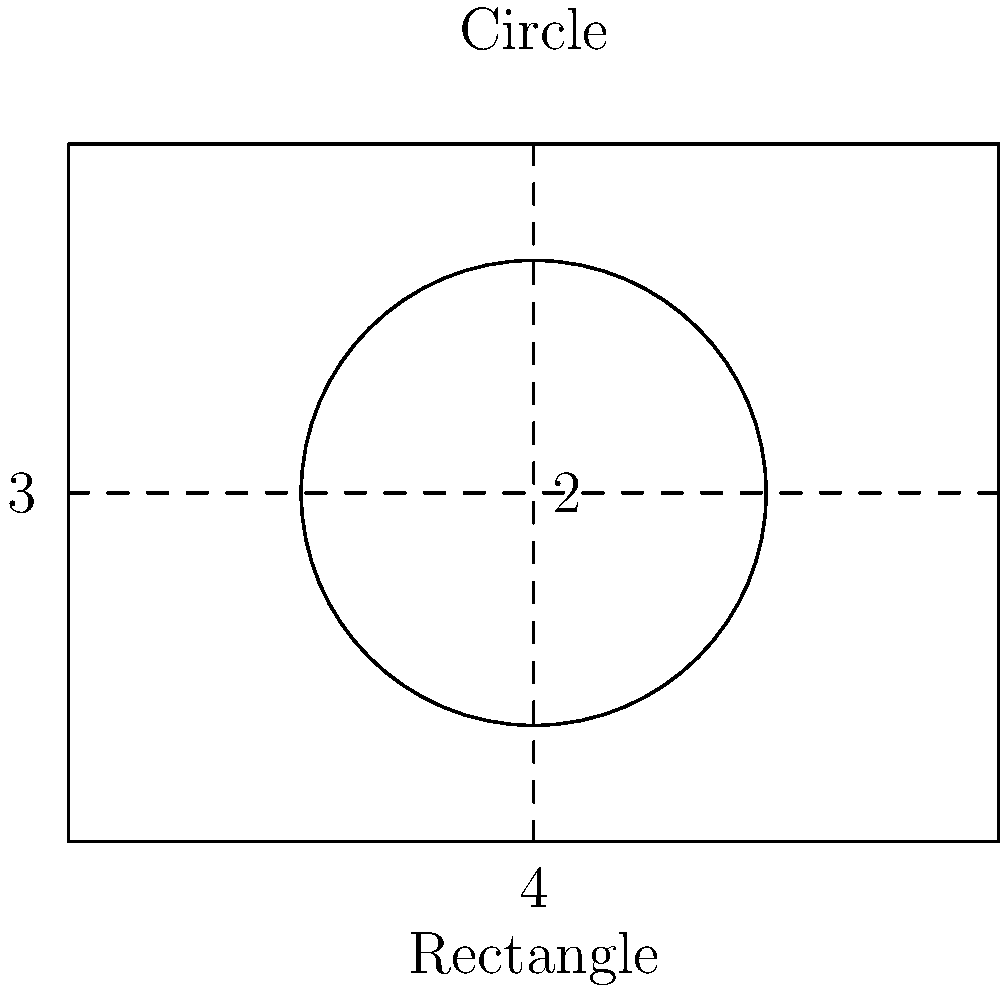You're designing new produce boxes for your CSA program. You have two options: a rectangular box with dimensions 4 units by 3 units, or a circular container with a diameter of 2 units. Assuming the height of both containers is the same, which shape will allow you to pack more produce by volume? Calculate the ratio of the circular container's volume to the rectangular box's volume. Let's approach this step-by-step:

1. Calculate the area of the rectangular box:
   Area of rectangle = length × width
   $A_r = 4 \times 3 = 12$ square units

2. Calculate the area of the circular container:
   Area of circle = $\pi r^2$, where $r$ is the radius (half the diameter)
   $A_c = \pi \times 1^2 = \pi$ square units

3. Since the height is the same for both containers, we can compare their volumes by comparing their areas. The ratio of volumes will be the same as the ratio of areas.

4. Calculate the ratio of the circular container's volume to the rectangular box's volume:
   Ratio = $\frac{A_c}{A_r} = \frac{\pi}{12}$

5. Simplify the ratio:
   $\frac{\pi}{12} \approx 0.2618$

6. Convert to a percentage:
   $0.2618 \times 100\% \approx 26.18\%$

This means the circular container has approximately 26.18% of the volume of the rectangular box.
Answer: $\frac{\pi}{12}$ or approximately 26.18% 